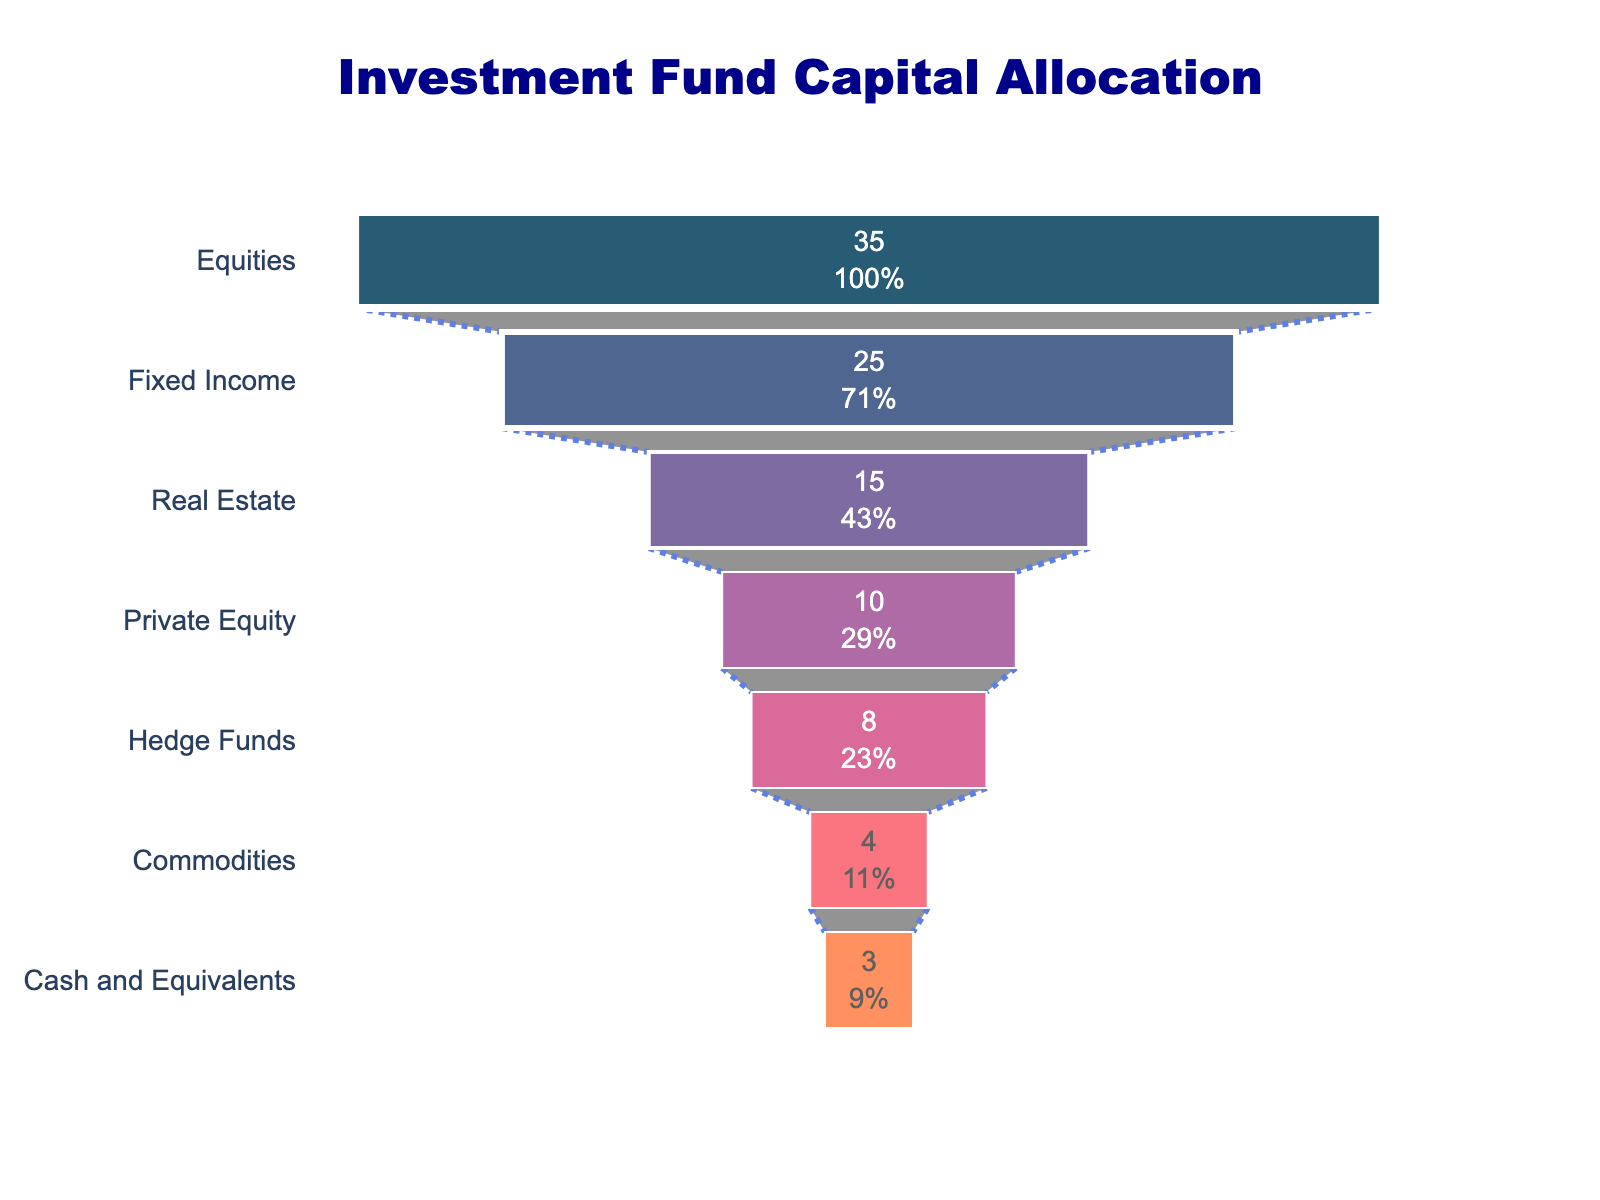what is the title of the figure? The title is typically located at the top center of the chart. For this Funnel Chart, the title is "Investment Fund Capital Allocation".
Answer: Investment Fund Capital Allocation How many asset classes are shown in the chart? By counting the number of horizontal bars or sections in the funnel chart, we can see there are seven asset classes listed.
Answer: Seven Which asset class has the highest allocation percentage? The highest allocation percentage can be observed at the widest section of the funnel. In this case, it is "Equities" with 35%.
Answer: Equities What is the total allocation percentage for Real Estate and Hedge Funds combined? The allocation percentage for Real Estate is 15%, and for Hedge Funds is 8%. Adding these two percentages gives 15% + 8% = 23%.
Answer: 23% Which asset class has the smallest allocation percentage? The smallest allocation percentage can be observed at the narrowest part of the funnel. In this case, it is "Cash and Equivalents" with 3%.
Answer: Cash and Equivalents What's the difference between the allocation percentages for Fixed Income and Private Equity? The allocation percentage for Fixed Income is 25% and for Private Equity is 10%. The difference is 25% - 10% = 15%.
Answer: 15% What percentage of the total fund is allocated to asset classes other than Equities and Fixed Income? Equities and Fixed Income together account for 35% + 25% = 60%. Therefore, the remaining percentage for other asset classes is 100% - 60% = 40%.
Answer: 40% Which asset classes have allocations greater than 10%? The allocations greater than 10% are found in the wider sections of the funnel. They are "Equities" (35%), "Fixed Income" (25%), and "Real Estate" (15%).
Answer: Equities, Fixed Income, Real Estate By how much does the allocation of Commodities exceed that of Cash and Equivalents? The allocation for Commodities is 4%, and for Cash and Equivalents is 3%. The difference is 4% - 3% = 1%.
Answer: 1% What percentage of the total fund is allocated to Hedge Funds and Commodities combined? Hedge Funds have an allocation of 8% and Commodities have 4%. Adding these two percentages gives 8% + 4% = 12%.
Answer: 12% 